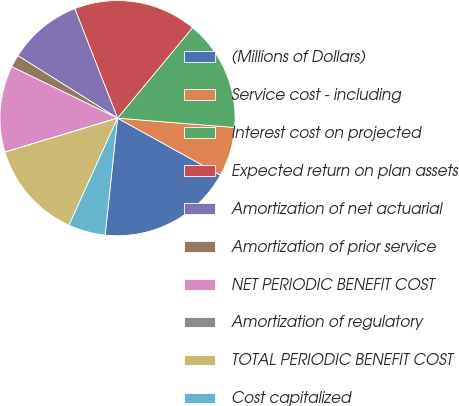Convert chart. <chart><loc_0><loc_0><loc_500><loc_500><pie_chart><fcel>(Millions of Dollars)<fcel>Service cost - including<fcel>Interest cost on projected<fcel>Expected return on plan assets<fcel>Amortization of net actuarial<fcel>Amortization of prior service<fcel>NET PERIODIC BENEFIT COST<fcel>Amortization of regulatory<fcel>TOTAL PERIODIC BENEFIT COST<fcel>Cost capitalized<nl><fcel>18.63%<fcel>6.79%<fcel>15.25%<fcel>16.94%<fcel>10.17%<fcel>1.71%<fcel>11.86%<fcel>0.02%<fcel>13.55%<fcel>5.09%<nl></chart> 